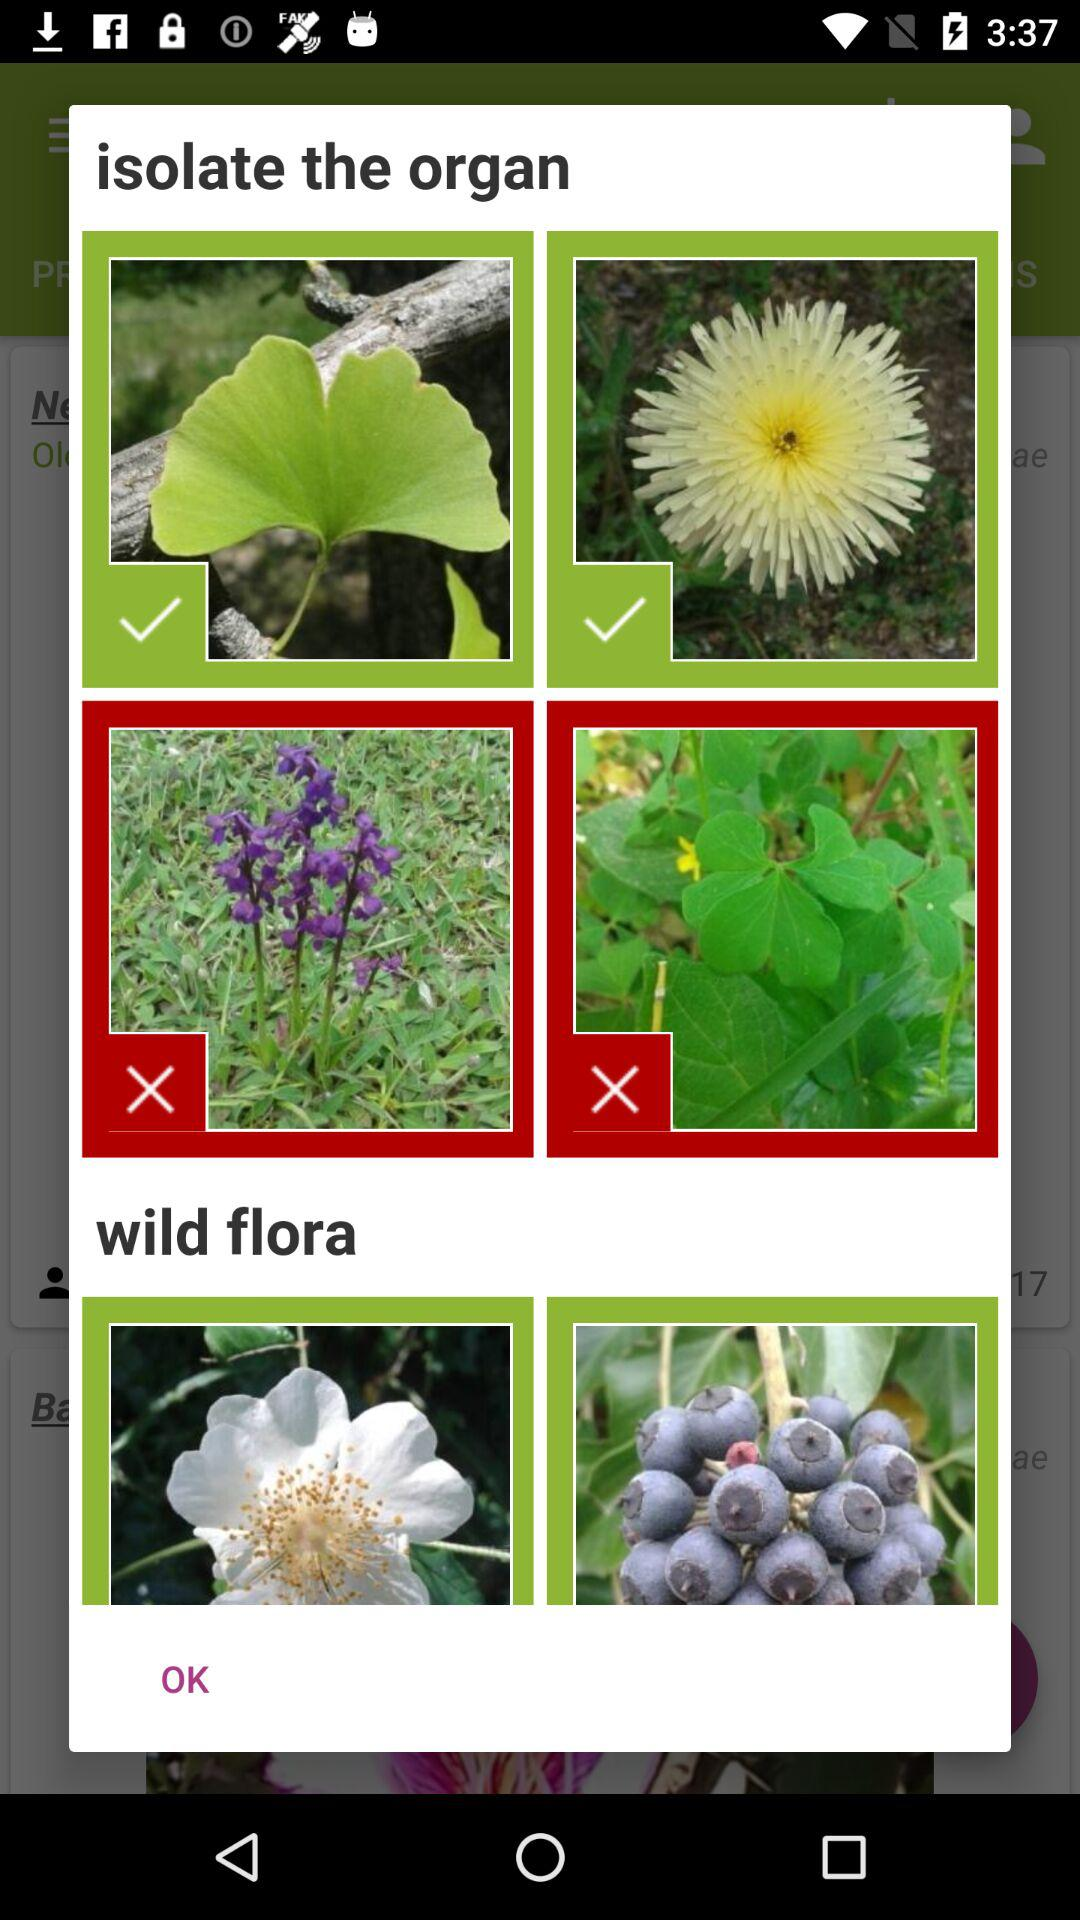How many check marks are there on the screen?
Answer the question using a single word or phrase. 2 